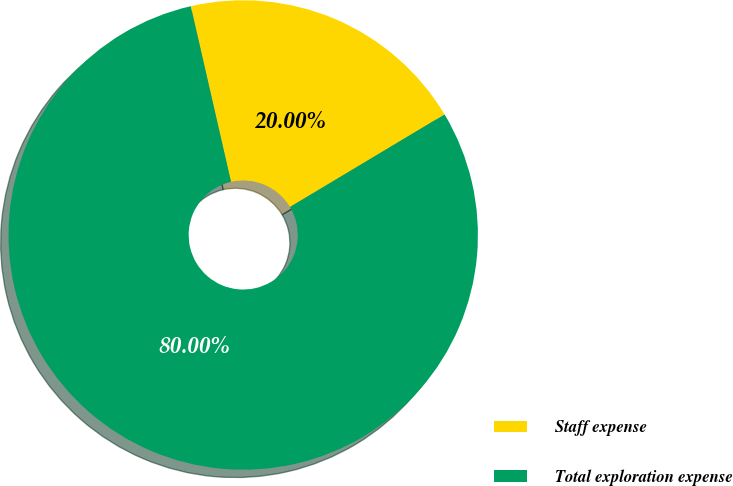Convert chart to OTSL. <chart><loc_0><loc_0><loc_500><loc_500><pie_chart><fcel>Staff expense<fcel>Total exploration expense<nl><fcel>20.0%<fcel>80.0%<nl></chart> 